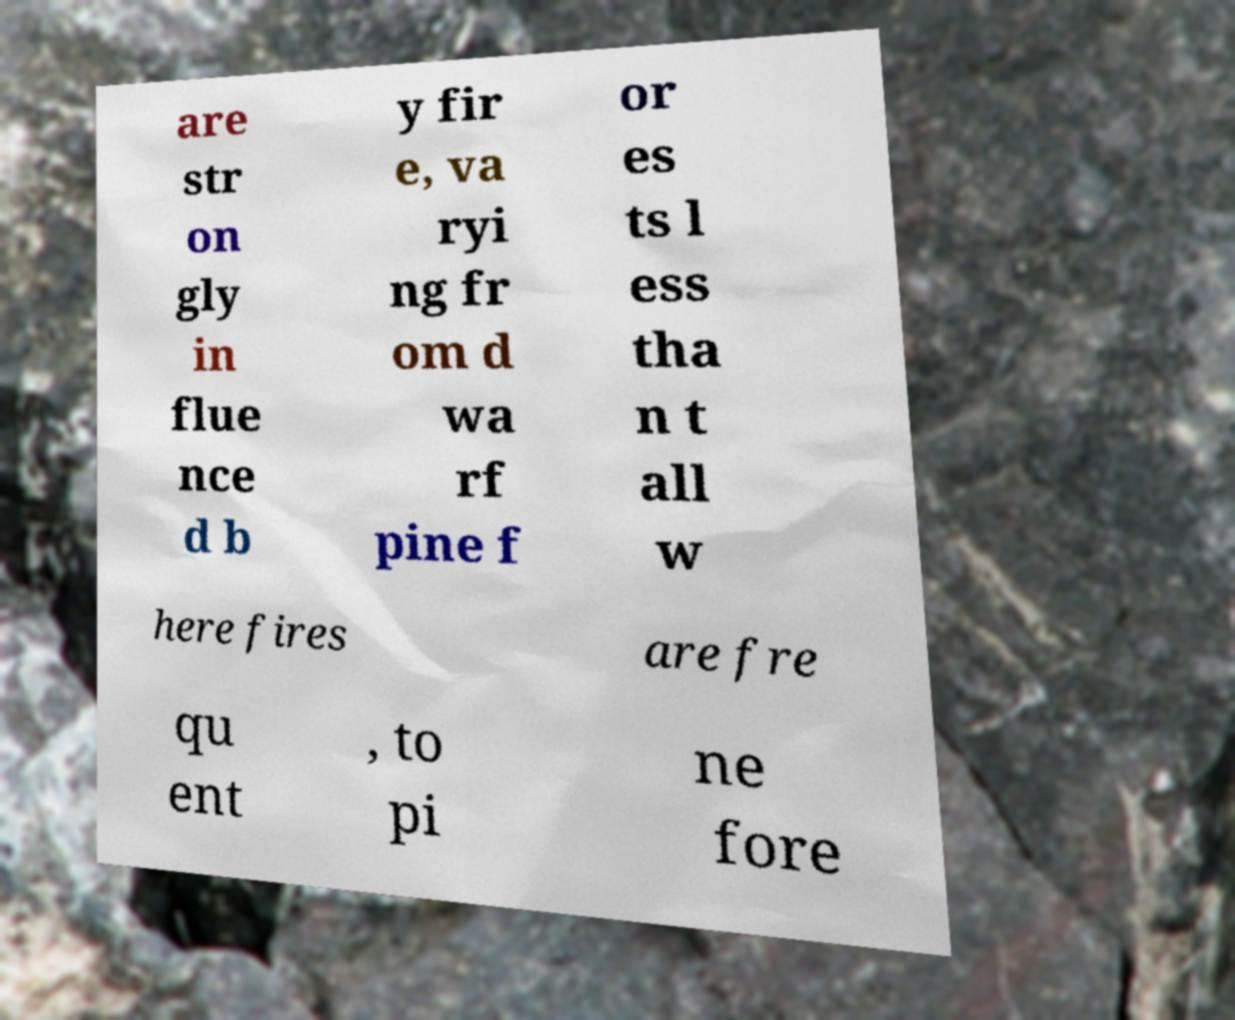Can you read and provide the text displayed in the image?This photo seems to have some interesting text. Can you extract and type it out for me? are str on gly in flue nce d b y fir e, va ryi ng fr om d wa rf pine f or es ts l ess tha n t all w here fires are fre qu ent , to pi ne fore 